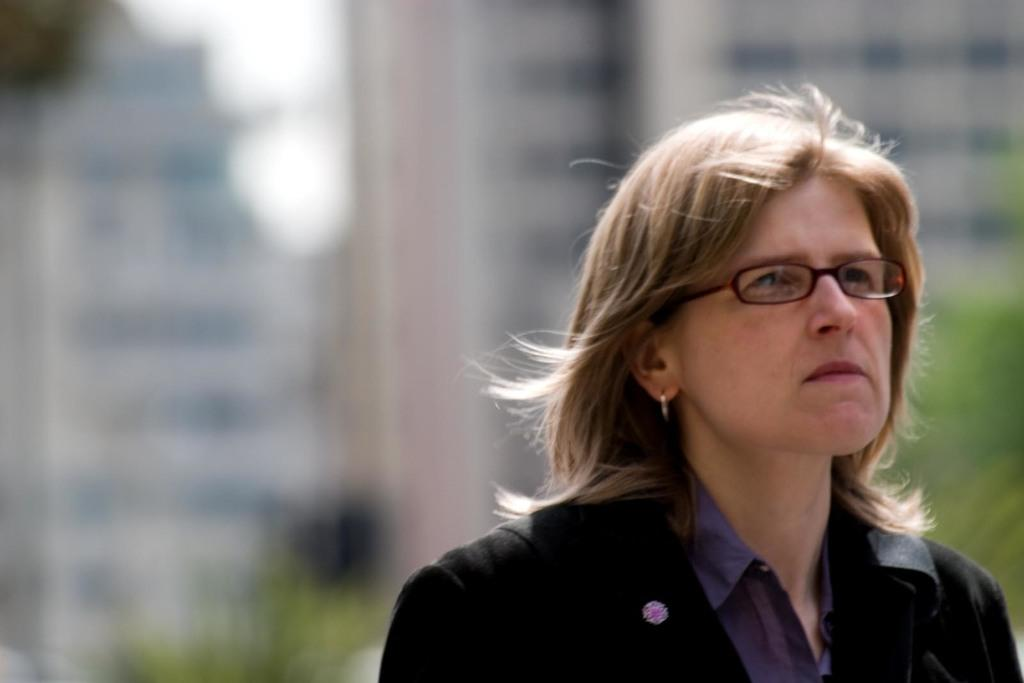Who is the main subject in the image? There is a woman in the image. What accessory is the woman wearing? The woman is wearing spectacles. Can you describe the background of the image? The background of the image is blurry. What type of bells can be heard ringing in the image? There are no bells present in the image, and therefore no sound can be heard. 